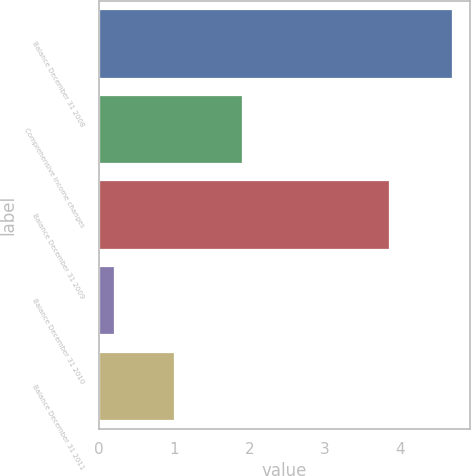<chart> <loc_0><loc_0><loc_500><loc_500><bar_chart><fcel>Balance December 31 2008<fcel>Comprehensive income changes<fcel>Balance December 31 2009<fcel>Balance December 31 2010<fcel>Balance December 31 2011<nl><fcel>4.7<fcel>1.9<fcel>3.85<fcel>0.2<fcel>1<nl></chart> 